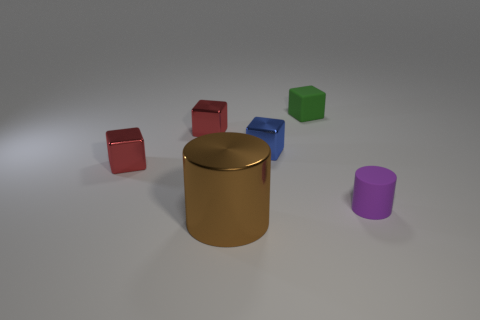What size is the other thing that is the same shape as the large brown shiny object?
Offer a terse response. Small. Are there any other things that are the same size as the purple matte cylinder?
Offer a very short reply. Yes. Are there fewer matte objects behind the small green thing than tiny blue rubber objects?
Your answer should be very brief. No. Is the big thing the same shape as the tiny green rubber thing?
Make the answer very short. No. There is a small matte thing that is the same shape as the large brown metallic object; what color is it?
Provide a short and direct response. Purple. What number of things are objects left of the purple object or cylinders?
Your answer should be very brief. 6. What size is the cube in front of the small blue metal thing?
Offer a terse response. Small. Is the number of small brown cubes less than the number of tiny green matte things?
Keep it short and to the point. Yes. Does the tiny cylinder in front of the tiny blue cube have the same material as the cylinder that is in front of the rubber cylinder?
Provide a short and direct response. No. What is the shape of the small purple rubber thing right of the cylinder to the left of the rubber object that is to the left of the purple rubber cylinder?
Your answer should be compact. Cylinder. 